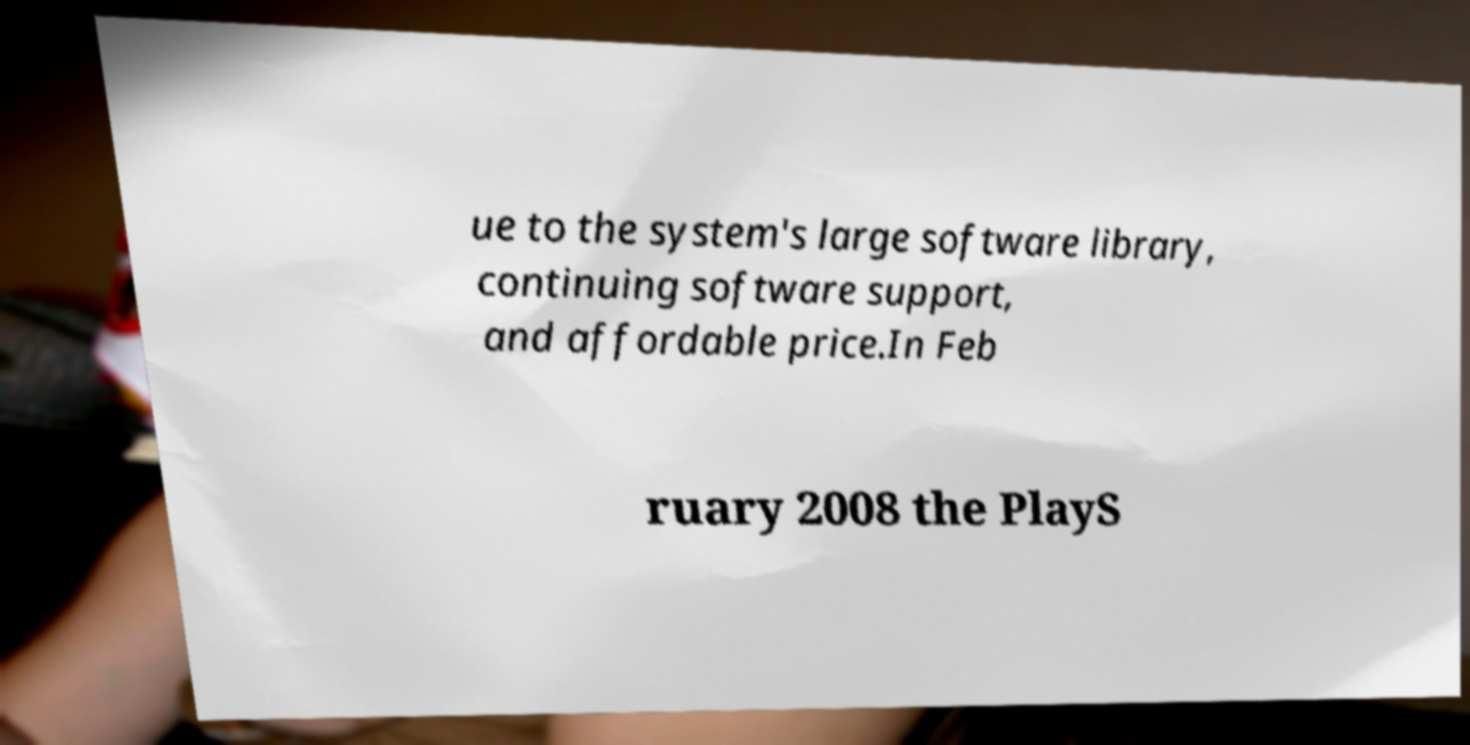For documentation purposes, I need the text within this image transcribed. Could you provide that? ue to the system's large software library, continuing software support, and affordable price.In Feb ruary 2008 the PlayS 